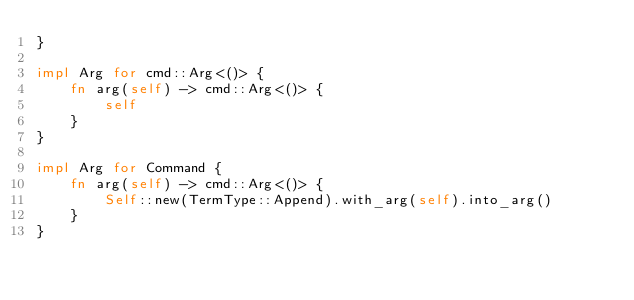<code> <loc_0><loc_0><loc_500><loc_500><_Rust_>}

impl Arg for cmd::Arg<()> {
    fn arg(self) -> cmd::Arg<()> {
        self
    }
}

impl Arg for Command {
    fn arg(self) -> cmd::Arg<()> {
        Self::new(TermType::Append).with_arg(self).into_arg()
    }
}
</code> 